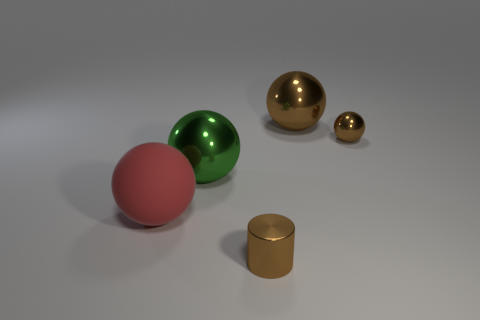Are there any tiny cyan cylinders made of the same material as the green ball?
Give a very brief answer. No. There is a tiny brown thing that is right of the big object on the right side of the tiny brown cylinder; what is its material?
Ensure brevity in your answer.  Metal. What is the size of the metal cylinder on the right side of the green metallic ball?
Provide a short and direct response. Small. There is a tiny cylinder; is it the same color as the big metallic ball to the left of the big brown sphere?
Your answer should be very brief. No. Is there a tiny metal object of the same color as the tiny ball?
Offer a very short reply. Yes. Are the tiny cylinder and the tiny thing that is behind the large red rubber ball made of the same material?
Offer a terse response. Yes. How many tiny objects are either balls or brown matte blocks?
Provide a short and direct response. 1. What material is the big object that is the same color as the metal cylinder?
Give a very brief answer. Metal. Is the number of brown things less than the number of tiny brown objects?
Ensure brevity in your answer.  No. There is a metal cylinder that is in front of the green metal object; is it the same size as the metallic thing that is to the left of the small brown metallic cylinder?
Offer a terse response. No. 